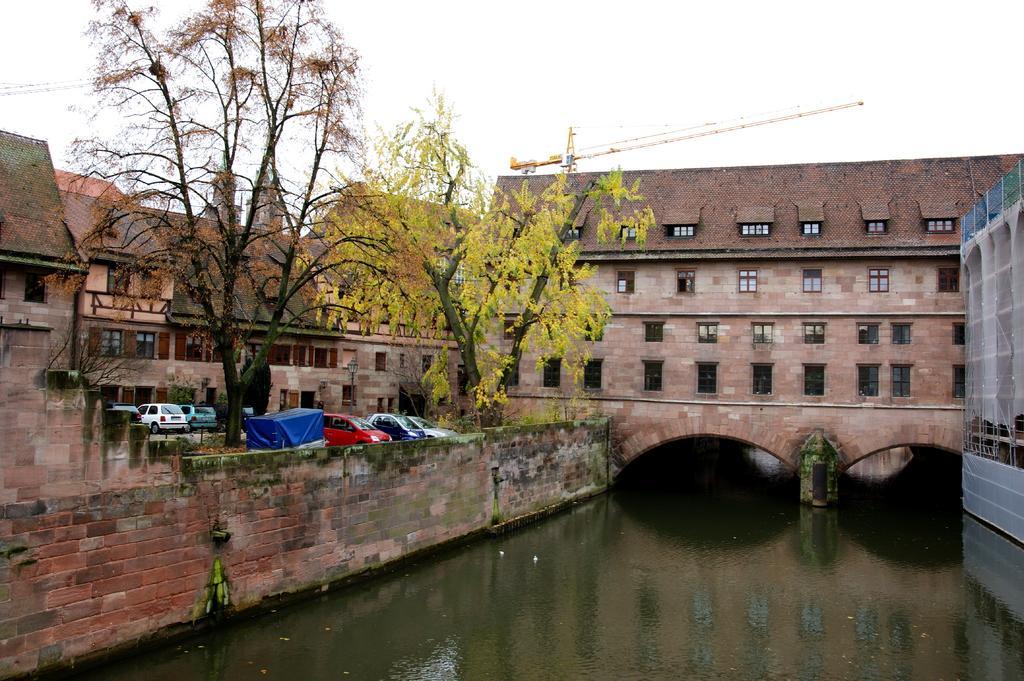In one or two sentences, can you explain what this image depicts? In this image there are buildings, in front of the buildings there are few cars parked, beside the cars there are trees, beside the building there is a pool of water. 